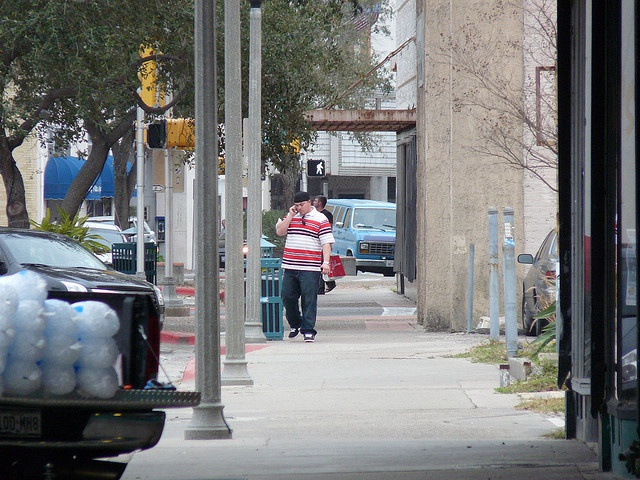Describe the objects in this image and their specific colors. I can see truck in black, darkgreen, gray, and navy tones, car in black, lightblue, gray, and darkgray tones, people in black, lavender, and darkgray tones, truck in black, darkgray, and lightblue tones, and car in black, darkgray, and gray tones in this image. 